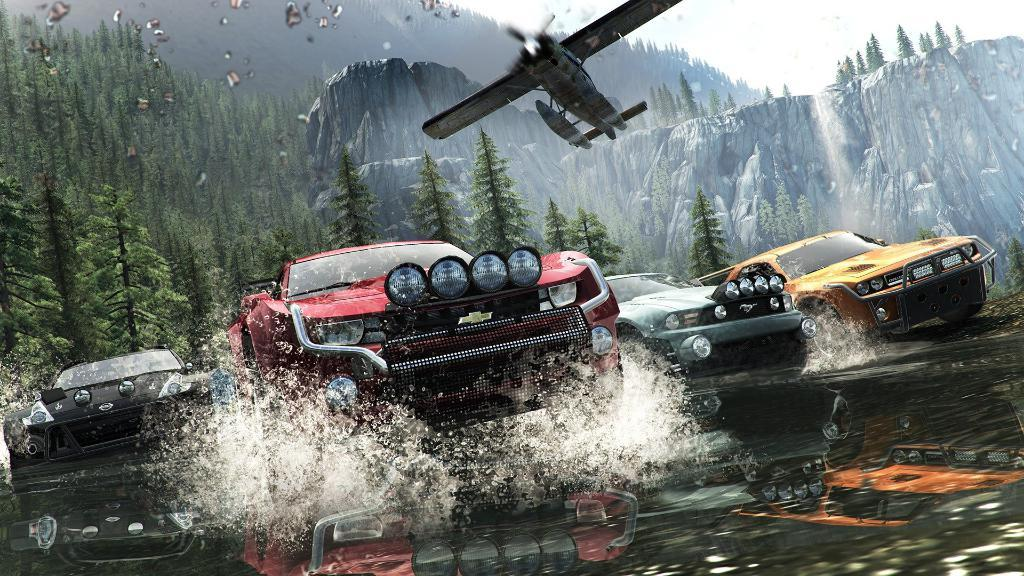What type of picture is the image? The image is an animated picture. What can be seen in the foreground of the image? There are cars and water in the foreground of the image. What is located in the center of the image? There are trees, mountains, and an aircraft in the center of the image. What is the condition of the sky in the image? The sky is cloudy in the image. What type of pain is the person in the image experiencing? There is no person present in the image, and therefore no indication of any pain being experienced. 